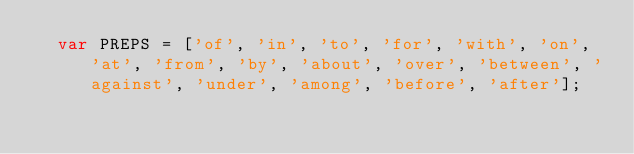Convert code to text. <code><loc_0><loc_0><loc_500><loc_500><_HTML_>	var PREPS = ['of', 'in', 'to', 'for', 'with', 'on', 'at', 'from', 'by', 'about', 'over', 'between', 'against', 'under', 'among', 'before', 'after'];</code> 